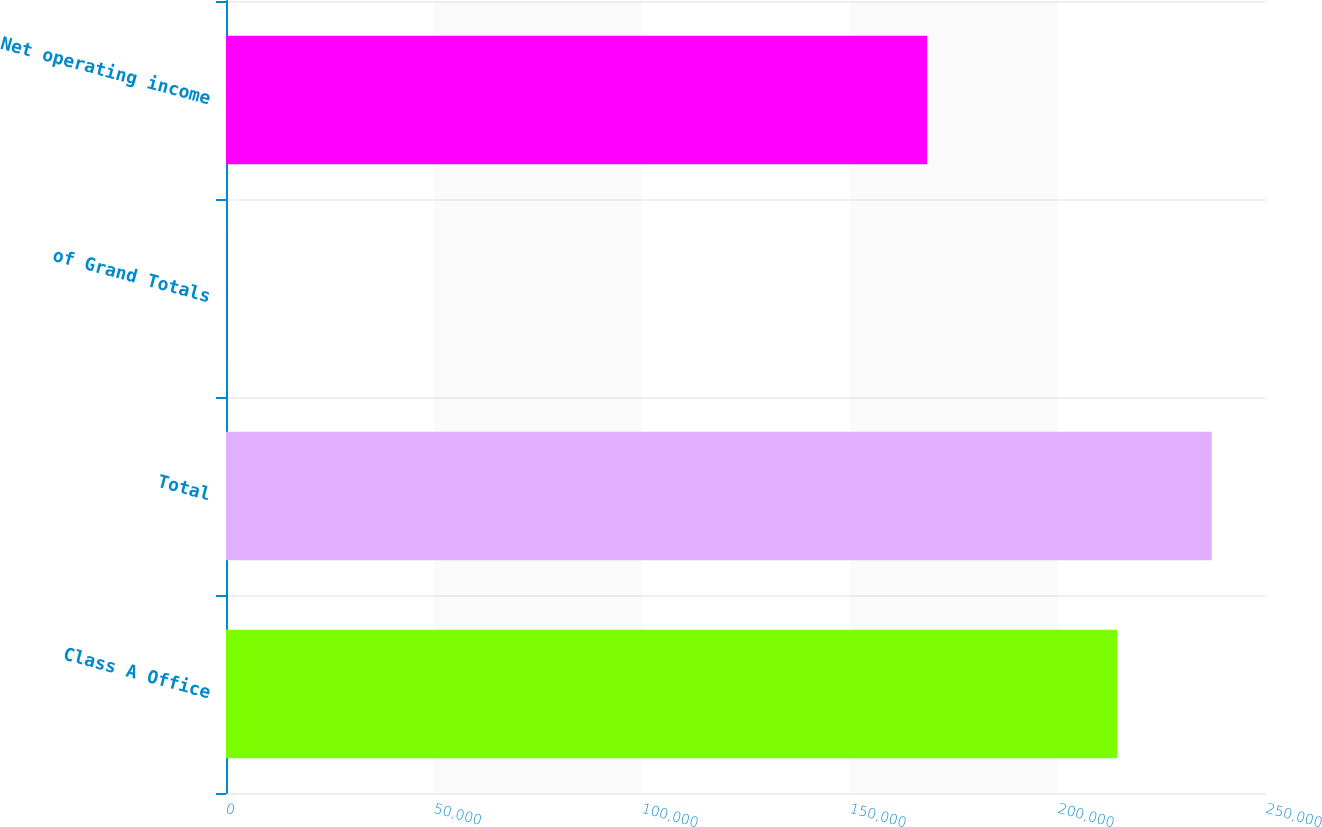Convert chart. <chart><loc_0><loc_0><loc_500><loc_500><bar_chart><fcel>Class A Office<fcel>Total<fcel>of Grand Totals<fcel>Net operating income<nl><fcel>214245<fcel>236987<fcel>16.71<fcel>168545<nl></chart> 